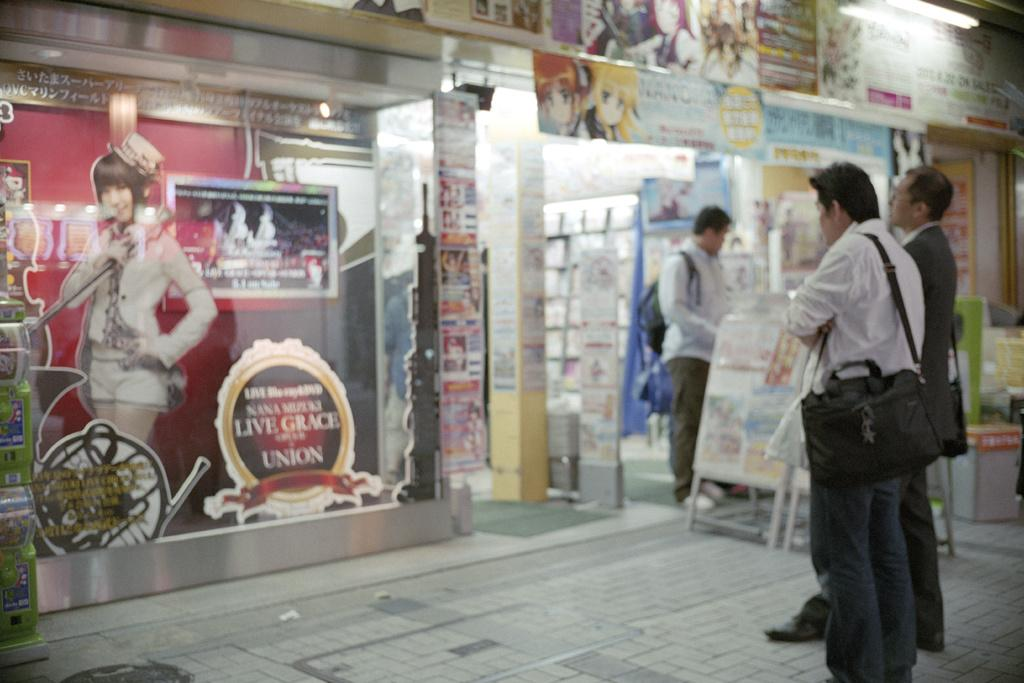<image>
Summarize the visual content of the image. People waiting outside a store with a sign that says "Live Grace Union". 